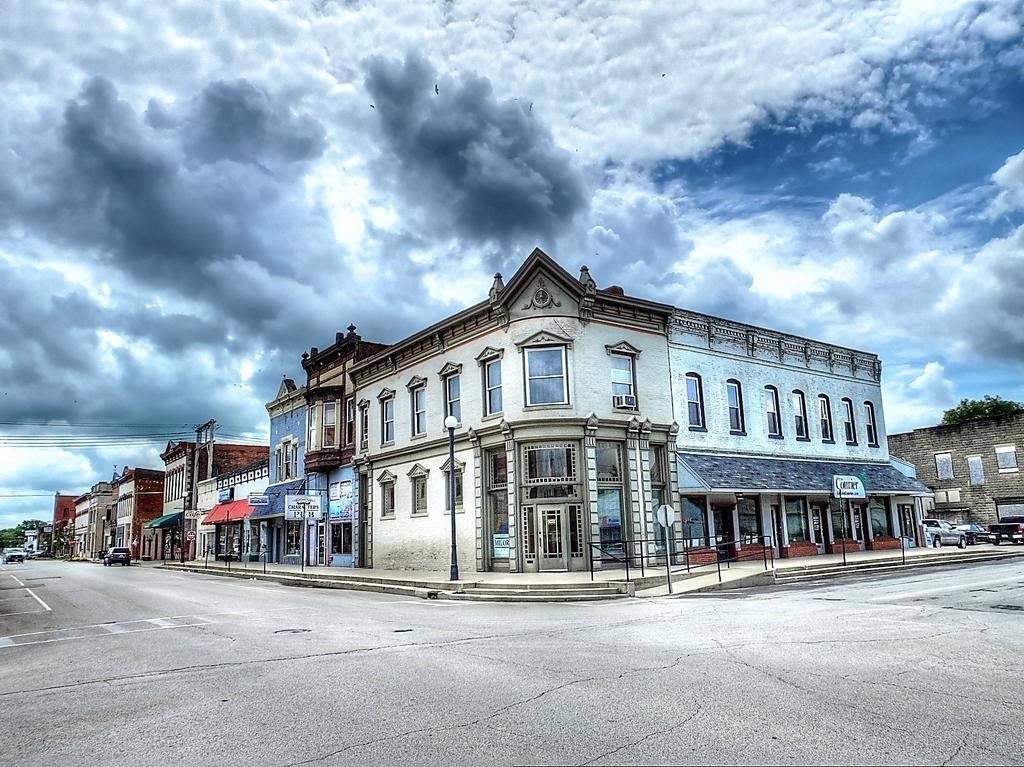What type of structures can be seen in the image? There are buildings in the image. What are the vertical objects in the image? There are poles in the image. What flat objects can be seen in the image? There are boards in the image. What type of transportation is present in the image? There are vehicles in the image. What type of vegetation is visible in the image? There are trees in the image. What surface can vehicles be seen traveling on in the image? There is a road in the image. What part of the natural environment is visible in the image? The sky is visible in the image, and there are clouds in the sky. Can you provide an example of a plot in the image? There is no plot present in the image, as it is a photograph and not a story. How does the move depicted in the image affect the surrounding environment? There is no move depicted in the image, as it is a still photograph. 